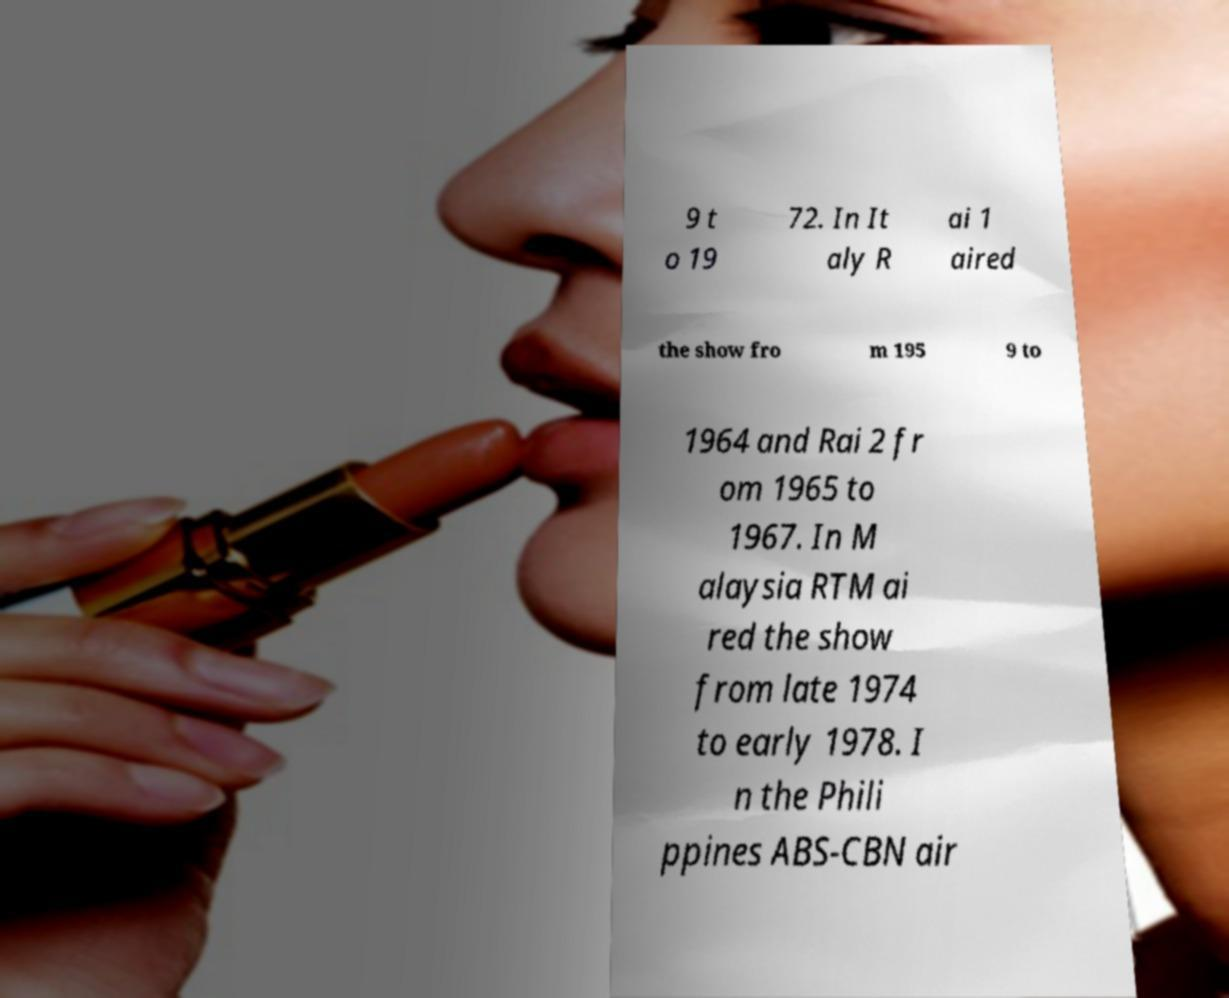I need the written content from this picture converted into text. Can you do that? 9 t o 19 72. In It aly R ai 1 aired the show fro m 195 9 to 1964 and Rai 2 fr om 1965 to 1967. In M alaysia RTM ai red the show from late 1974 to early 1978. I n the Phili ppines ABS-CBN air 